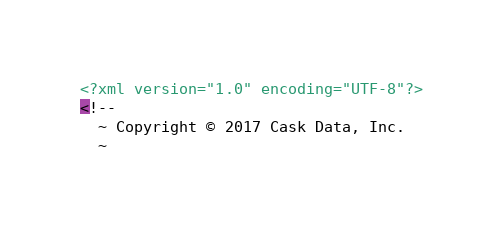Convert code to text. <code><loc_0><loc_0><loc_500><loc_500><_XML_><?xml version="1.0" encoding="UTF-8"?>
<!--
  ~ Copyright © 2017 Cask Data, Inc.
  ~</code> 